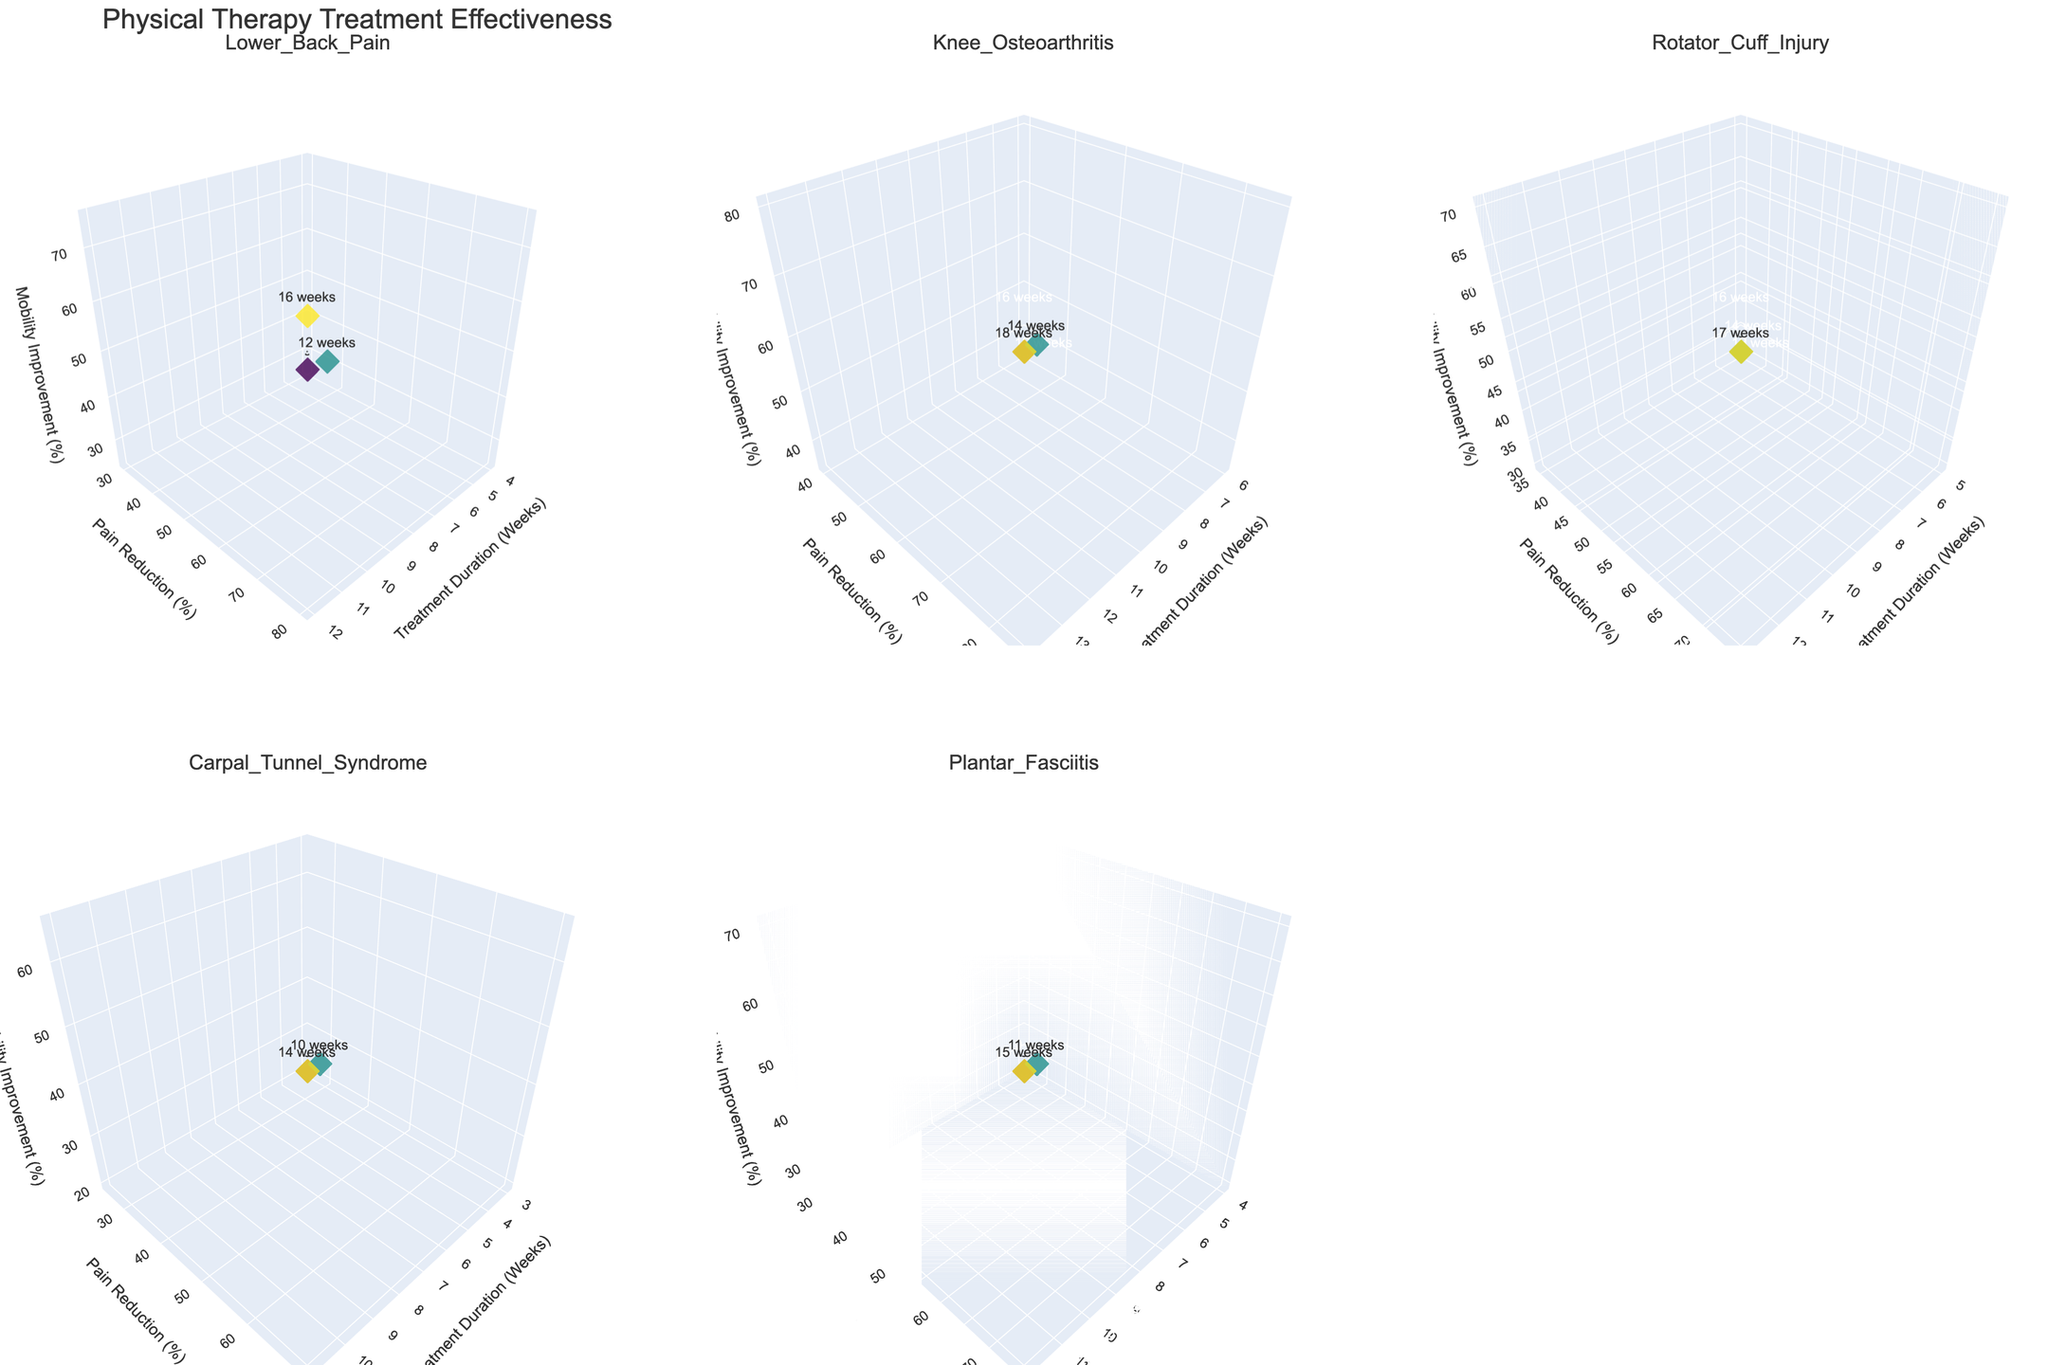What is the title of the figure? The title of the figure is typically placed at the top and gives an overview of what the figure represents. In this case, it reads "Physical Therapy Treatment Effectiveness."
Answer: Physical Therapy Treatment Effectiveness What is the treatment duration range for Knee Osteoarthritis? By examining the subplot for Knee Osteoarthritis, observe the x-axis values, which indicate the treatment duration in weeks. The range spans from 6 to 14 weeks.
Answer: 6 to 14 weeks Which condition shows the highest percentage of pain reduction? To answer this, look at the highest point on the y-axis across all subplots. The Knee Osteoarthritis subplot shows values up to 85%, which is the highest among all conditions.
Answer: Knee Osteoarthritis How many data points are there for the condition Rotator Cuff Injury? Count the markers in the subplot for Rotator Cuff Injury. Each marker represents a data point, and there are 3 markers.
Answer: 3 Which conditions have a pain reduction percentage that exceeds 70%? Compare all subplots and identify the conditions with y-axis values (pain reduction percentage) greater than 70. Both Knee Osteoarthritis and Plantar Fasciitis have markers above 70%.
Answer: Knee Osteoarthritis, Plantar Fasciitis What it the recovery time for Lower Back Pain at 12 weeks of treatment? In the Lower Back Pain subplot, locate the marker corresponding to a treatment duration of 12 weeks on the x-axis and refer to its associated text or hover information, which shows a recovery time of 16 weeks.
Answer: 16 weeks What is the mobility improvement percentage for Carpal Tunnel Syndrome at 7 weeks of treatment? In the Carpal Tunnel Syndrome subplot, find the marker corresponding to a treatment duration of 7 weeks (x-axis). Check the z-axis value for that marker, which indicates a mobility improvement percentage of 45%.
Answer: 45% Which condition has the longest recovery time? Evaluate the hover texts or colors of markers across all subplots, observing the recovery times. The maximum recovery time of 18 weeks is for Knee Osteoarthritis.
Answer: Knee Osteoarthritis What is the average pain reduction percentage for Lower Back Pain? Sum the pain reduction percentages for Lower Back Pain (30%, 60%, 80%) and divide by the number of data points. (30 + 60 + 80) / 3 = 56.67%.
Answer: 56.67% How does the mobility improvement percentage at 5 weeks for Rotator Cuff Injury compare to the same duration for Lower Back Pain? Check the z-axis value for the 5-week marker in the Rotator Cuff Injury subplot (30%) and compare it to the z-axis value at 4 weeks (closest to 5 weeks available) for Lower Back Pain (25%). Rotator Cuff Injury has a higher value.
Answer: Rotator Cuff Injury has a higher value 